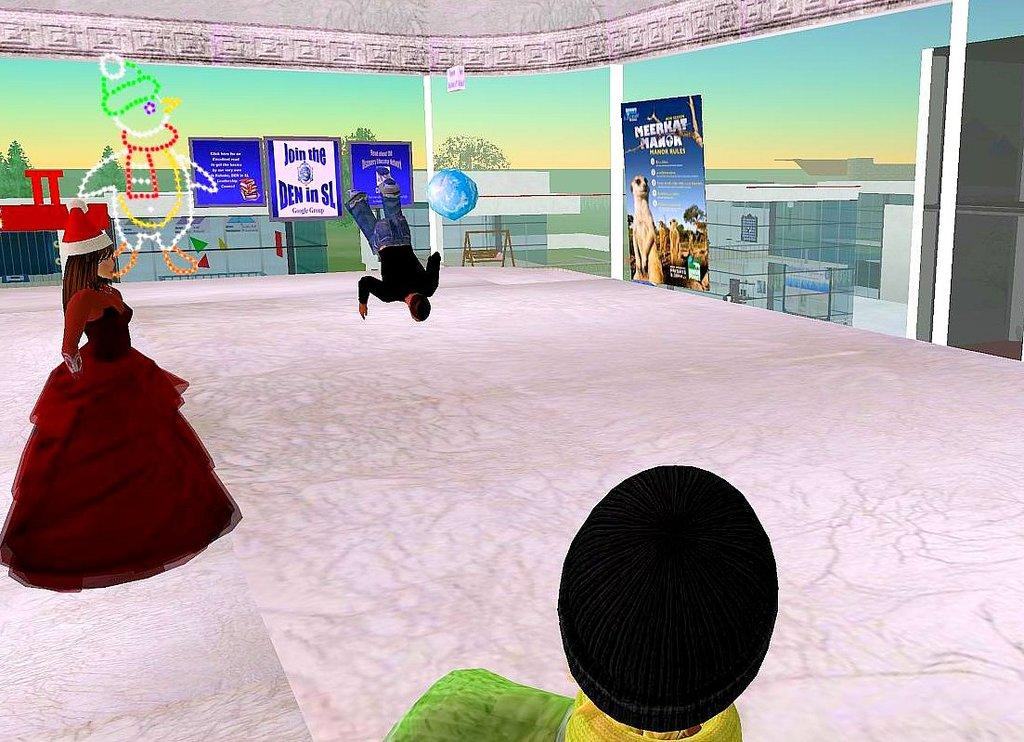What type of visual content is depicted in the image? The image is an animation. Can you describe the characters in the animation? There are people in the image. What object can be seen in the image that is commonly used for play? There is a ball in the image. What type of structure is present in the image? There are boards in the image. What playground equipment is visible in the image? There is a swing in the image. What type of natural elements can be seen in the image? There are trees in the image. What other objects can be seen in the image? There are various objects in the image. What is visible in the background of the image? The sky is visible in the image. How many pies are being baked by the cats in the image? There are no cats or pies present in the image. What type of waste is being disposed of in the image? There is no waste present in the image. 